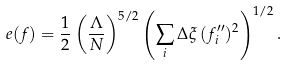Convert formula to latex. <formula><loc_0><loc_0><loc_500><loc_500>e ( f ) = \frac { 1 } { 2 } \left ( \frac { \Lambda } { N } \right ) ^ { 5 / 2 } \left ( \sum _ { i } \Delta \xi \, ( f ^ { \prime \prime } _ { i } ) ^ { 2 } \right ) ^ { 1 / 2 } .</formula> 